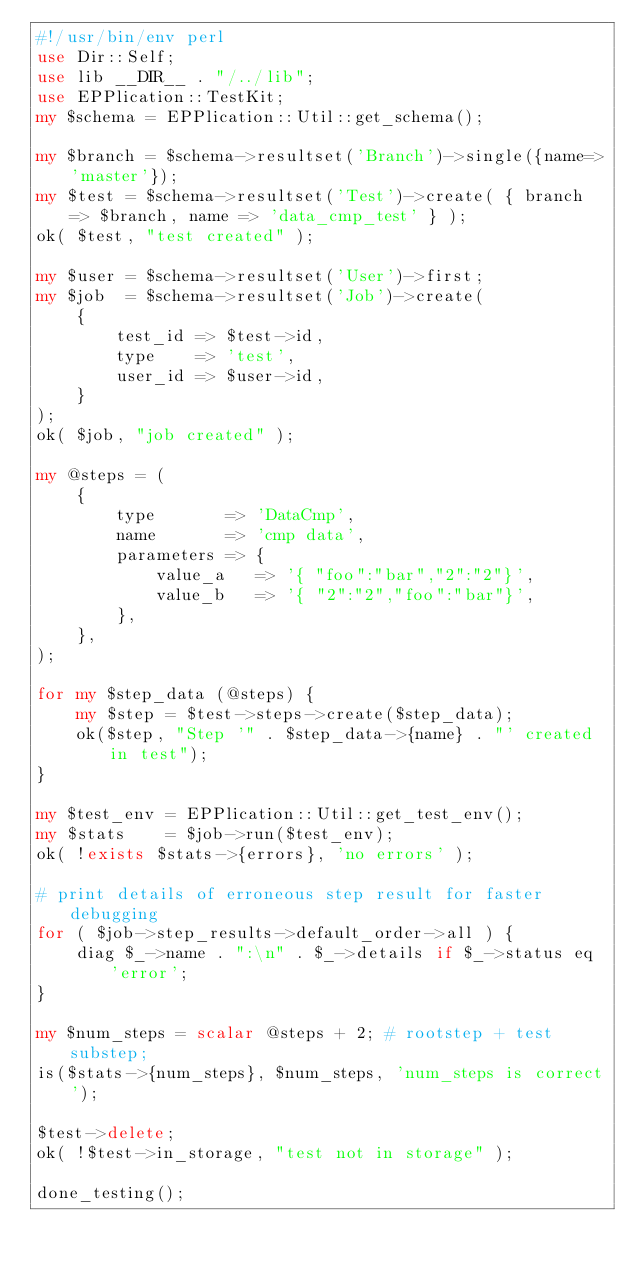<code> <loc_0><loc_0><loc_500><loc_500><_Perl_>#!/usr/bin/env perl
use Dir::Self;
use lib __DIR__ . "/../lib";
use EPPlication::TestKit;
my $schema = EPPlication::Util::get_schema();

my $branch = $schema->resultset('Branch')->single({name=>'master'});
my $test = $schema->resultset('Test')->create( { branch => $branch, name => 'data_cmp_test' } );
ok( $test, "test created" );

my $user = $schema->resultset('User')->first;
my $job  = $schema->resultset('Job')->create(
    {
        test_id => $test->id,
        type    => 'test',
        user_id => $user->id,
    }
);
ok( $job, "job created" );

my @steps = (
    {
        type       => 'DataCmp',
        name       => 'cmp data',
        parameters => {
            value_a   => '{ "foo":"bar","2":"2"}',
            value_b   => '{ "2":"2","foo":"bar"}',
        },
    },
);

for my $step_data (@steps) {
    my $step = $test->steps->create($step_data);
    ok($step, "Step '" . $step_data->{name} . "' created in test");
}

my $test_env = EPPlication::Util::get_test_env();
my $stats    = $job->run($test_env);
ok( !exists $stats->{errors}, 'no errors' );

# print details of erroneous step result for faster debugging
for ( $job->step_results->default_order->all ) {
    diag $_->name . ":\n" . $_->details if $_->status eq 'error';
}

my $num_steps = scalar @steps + 2; # rootstep + test substep;
is($stats->{num_steps}, $num_steps, 'num_steps is correct');

$test->delete;
ok( !$test->in_storage, "test not in storage" );

done_testing();
</code> 